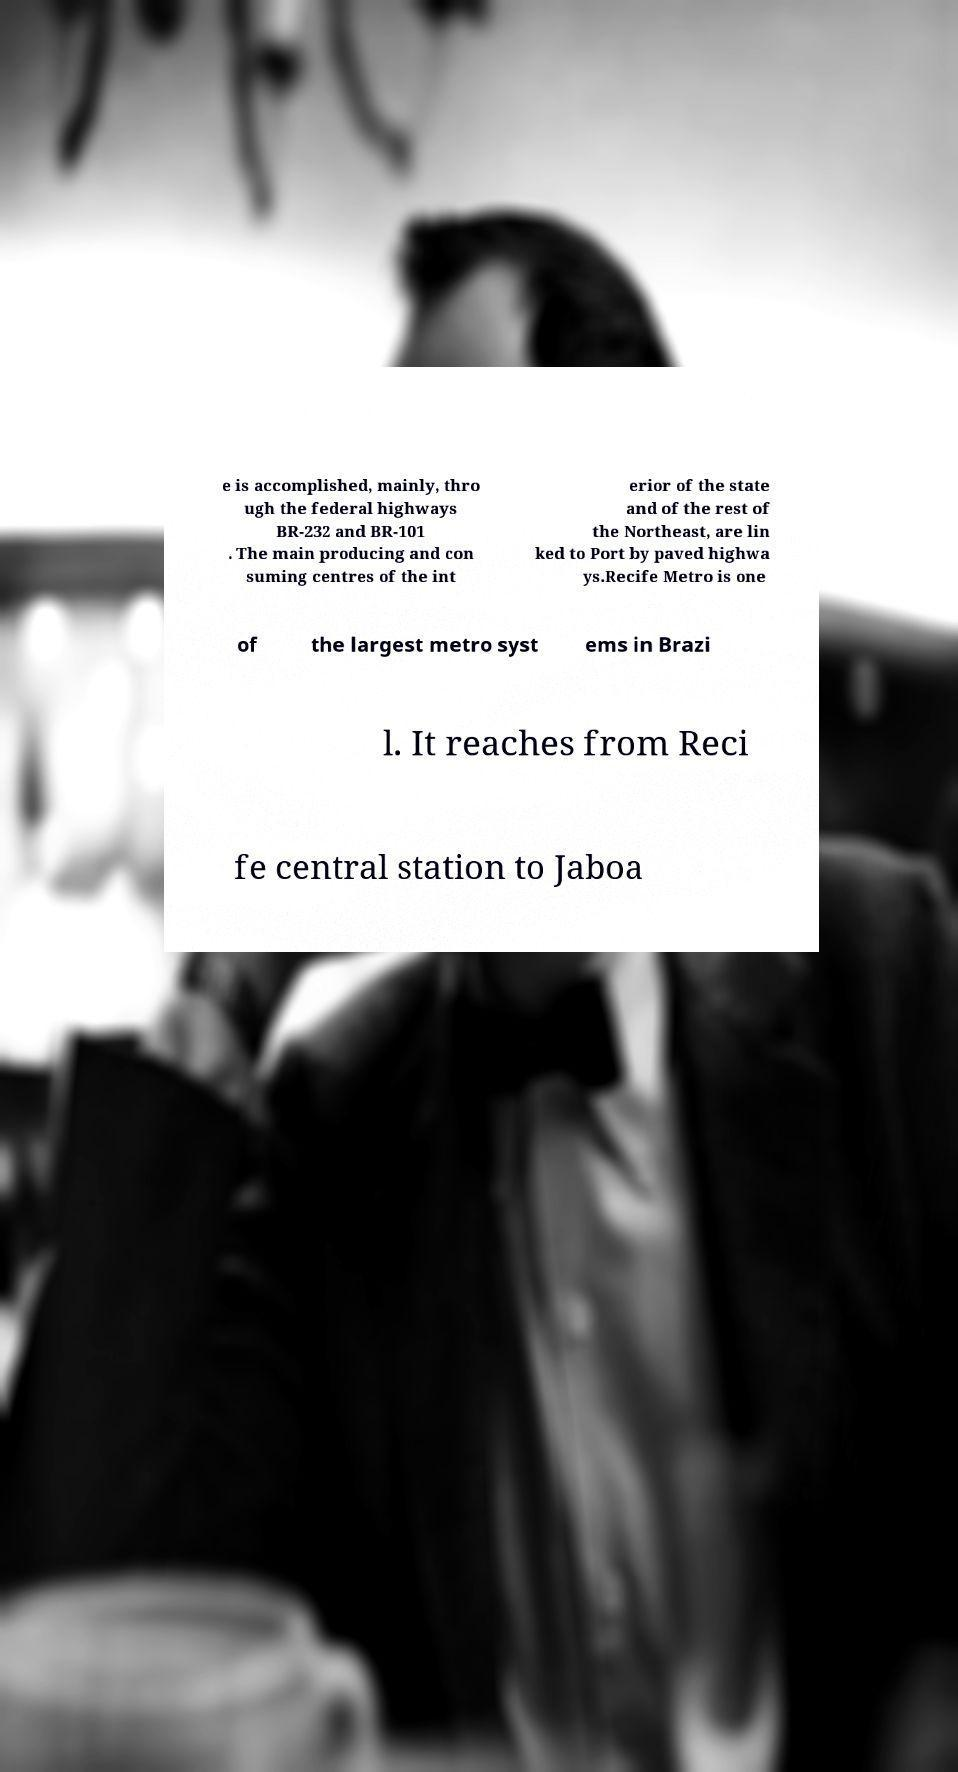For documentation purposes, I need the text within this image transcribed. Could you provide that? e is accomplished, mainly, thro ugh the federal highways BR-232 and BR-101 . The main producing and con suming centres of the int erior of the state and of the rest of the Northeast, are lin ked to Port by paved highwa ys.Recife Metro is one of the largest metro syst ems in Brazi l. It reaches from Reci fe central station to Jaboa 